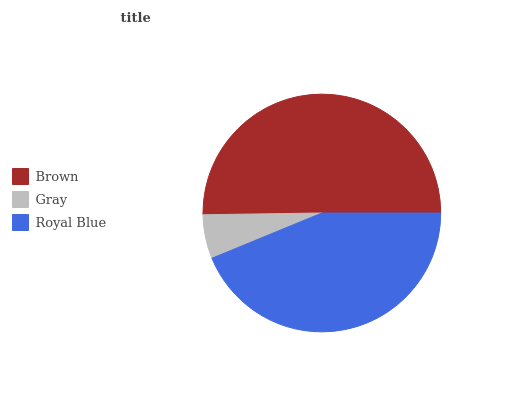Is Gray the minimum?
Answer yes or no. Yes. Is Brown the maximum?
Answer yes or no. Yes. Is Royal Blue the minimum?
Answer yes or no. No. Is Royal Blue the maximum?
Answer yes or no. No. Is Royal Blue greater than Gray?
Answer yes or no. Yes. Is Gray less than Royal Blue?
Answer yes or no. Yes. Is Gray greater than Royal Blue?
Answer yes or no. No. Is Royal Blue less than Gray?
Answer yes or no. No. Is Royal Blue the high median?
Answer yes or no. Yes. Is Royal Blue the low median?
Answer yes or no. Yes. Is Brown the high median?
Answer yes or no. No. Is Brown the low median?
Answer yes or no. No. 